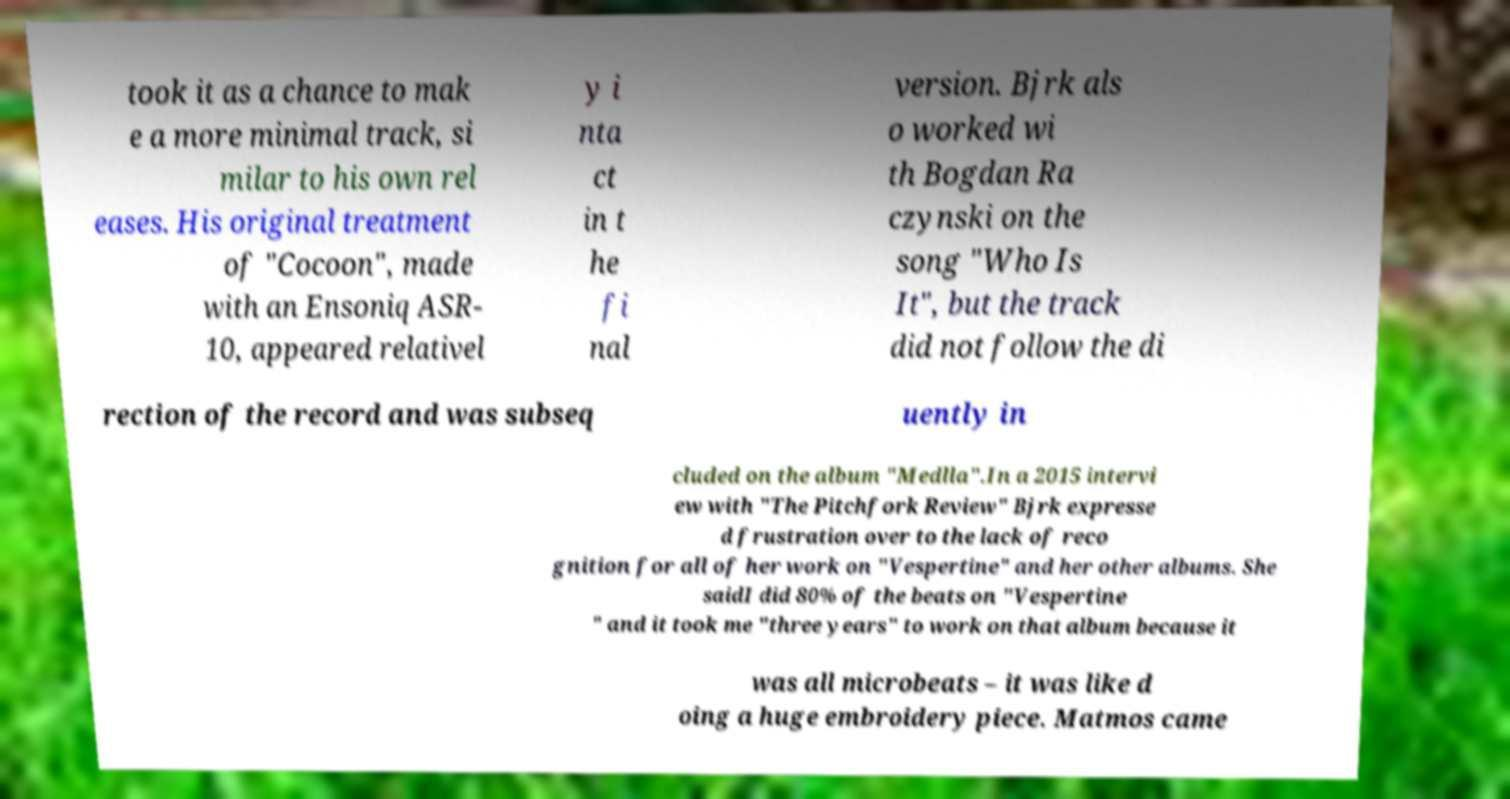Please identify and transcribe the text found in this image. took it as a chance to mak e a more minimal track, si milar to his own rel eases. His original treatment of "Cocoon", made with an Ensoniq ASR- 10, appeared relativel y i nta ct in t he fi nal version. Bjrk als o worked wi th Bogdan Ra czynski on the song "Who Is It", but the track did not follow the di rection of the record and was subseq uently in cluded on the album "Medlla".In a 2015 intervi ew with "The Pitchfork Review" Bjrk expresse d frustration over to the lack of reco gnition for all of her work on "Vespertine" and her other albums. She saidI did 80% of the beats on "Vespertine " and it took me "three years" to work on that album because it was all microbeats – it was like d oing a huge embroidery piece. Matmos came 